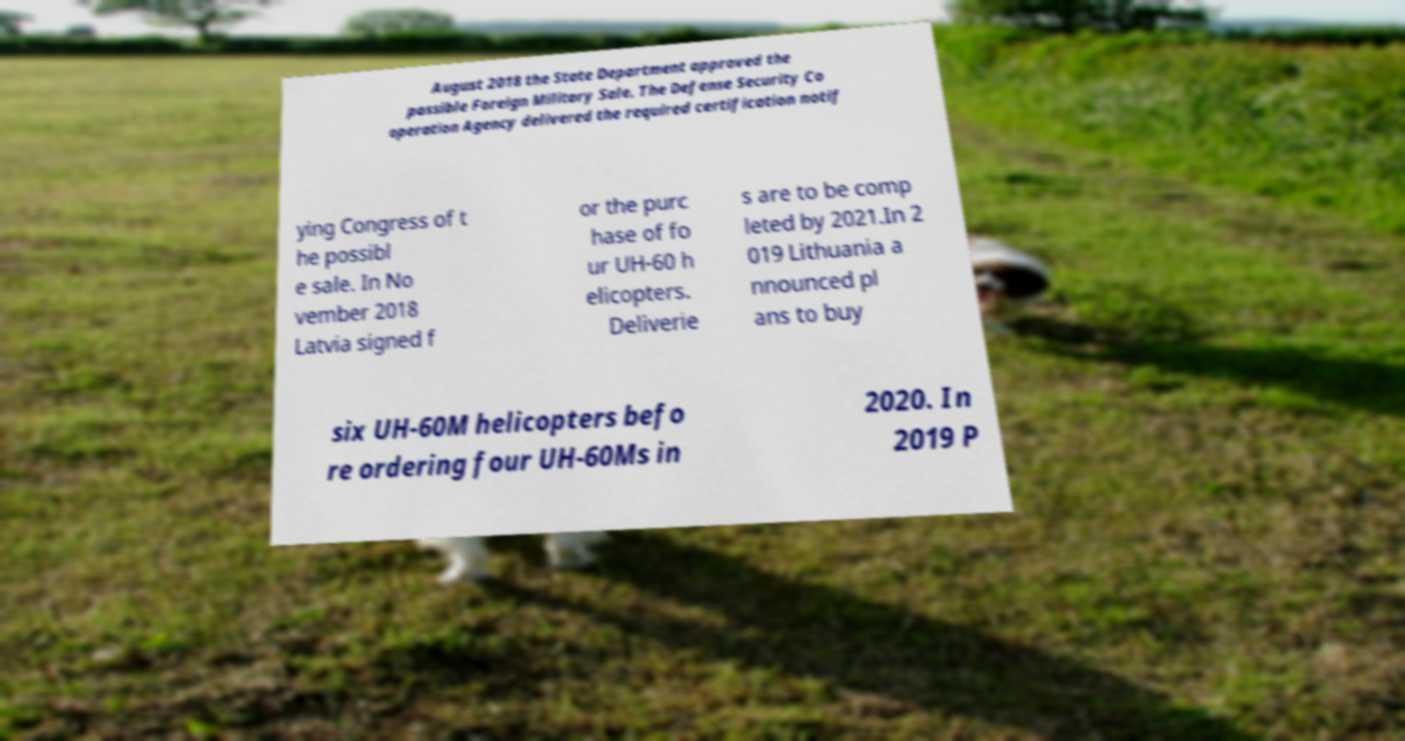Could you extract and type out the text from this image? August 2018 the State Department approved the possible Foreign Military Sale. The Defense Security Co operation Agency delivered the required certification notif ying Congress of t he possibl e sale. In No vember 2018 Latvia signed f or the purc hase of fo ur UH-60 h elicopters. Deliverie s are to be comp leted by 2021.In 2 019 Lithuania a nnounced pl ans to buy six UH-60M helicopters befo re ordering four UH-60Ms in 2020. In 2019 P 